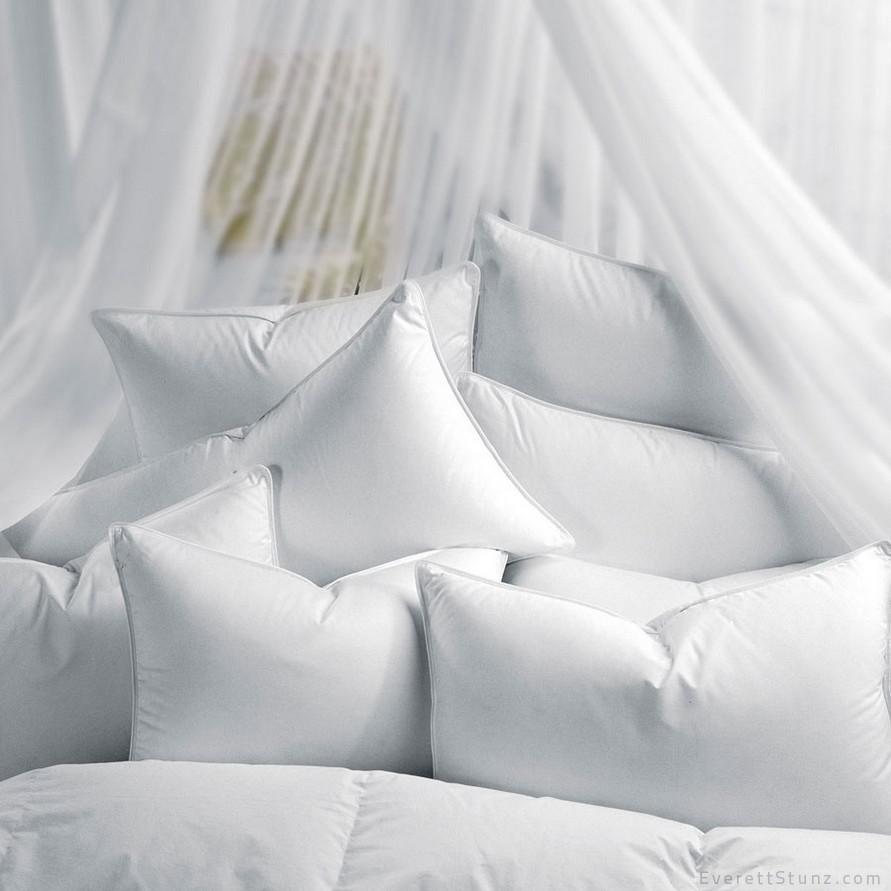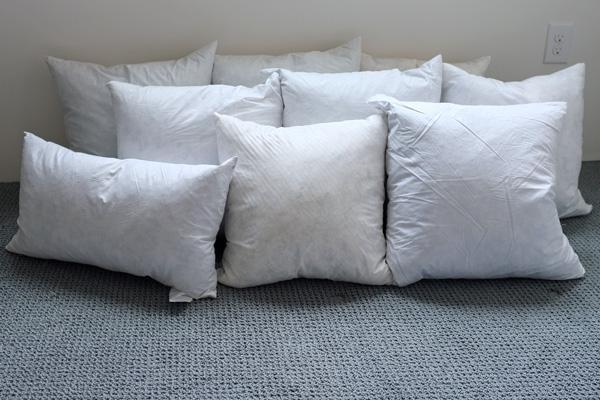The first image is the image on the left, the second image is the image on the right. Considering the images on both sides, is "Every photo features less than four white pillows all displayed inside a home." valid? Answer yes or no. No. 